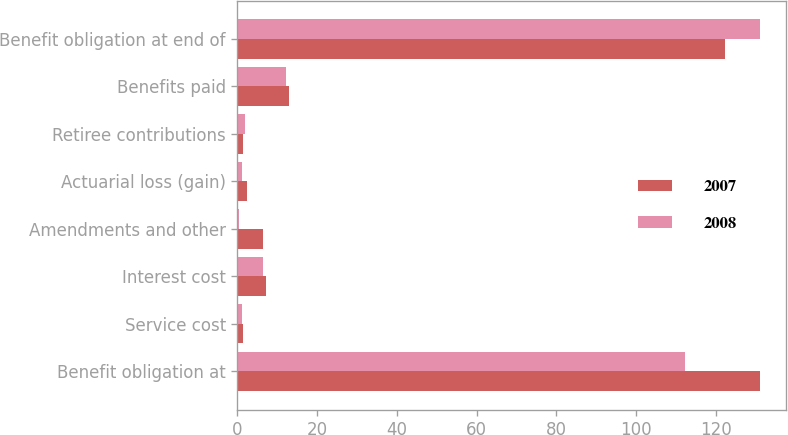Convert chart to OTSL. <chart><loc_0><loc_0><loc_500><loc_500><stacked_bar_chart><ecel><fcel>Benefit obligation at<fcel>Service cost<fcel>Interest cost<fcel>Amendments and other<fcel>Actuarial loss (gain)<fcel>Retiree contributions<fcel>Benefits paid<fcel>Benefit obligation at end of<nl><fcel>2007<fcel>131.2<fcel>1.3<fcel>7.1<fcel>6.3<fcel>2.3<fcel>1.5<fcel>13<fcel>122.4<nl><fcel>2008<fcel>112.3<fcel>1.2<fcel>6.5<fcel>0.3<fcel>1.1<fcel>1.9<fcel>12.3<fcel>131.2<nl></chart> 